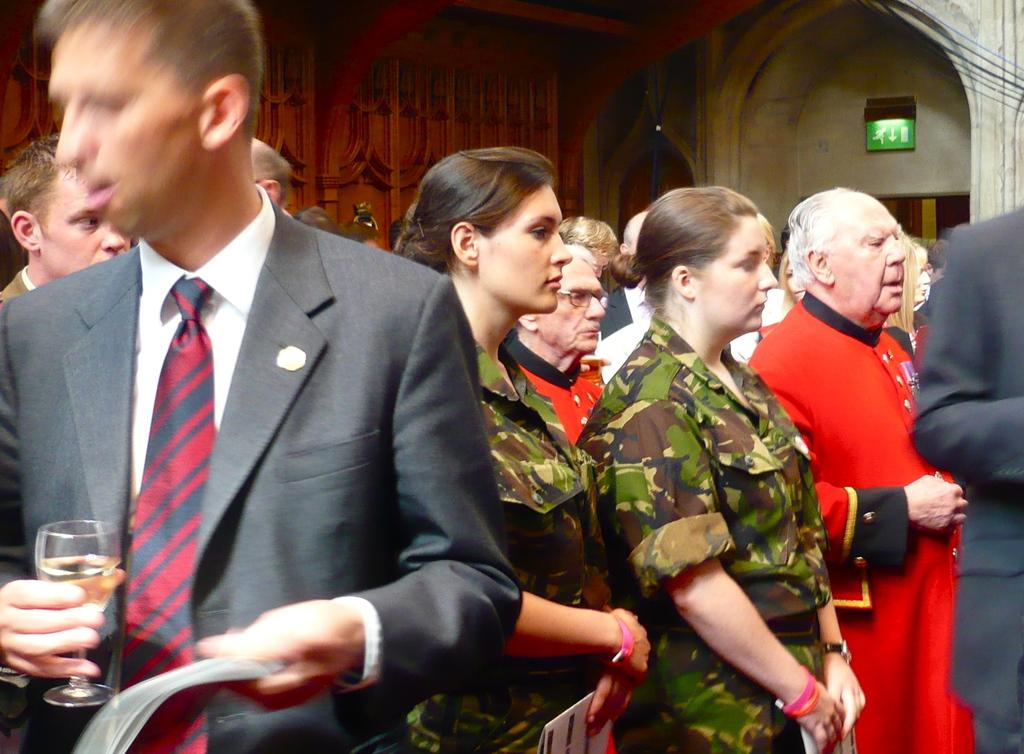How many people are in the image? There is a group of people in the image, but the exact number is not specified. What are some people doing in the image? Some people are holding items in the image. What can be seen in the background of the image? There is a wall and a sign board in the background of the image. What type of crack can be heard in the image? There is no sound, such as a crack, present in the image. How many times does the person in the image shake their head? There is no indication of any head shaking in the image. 